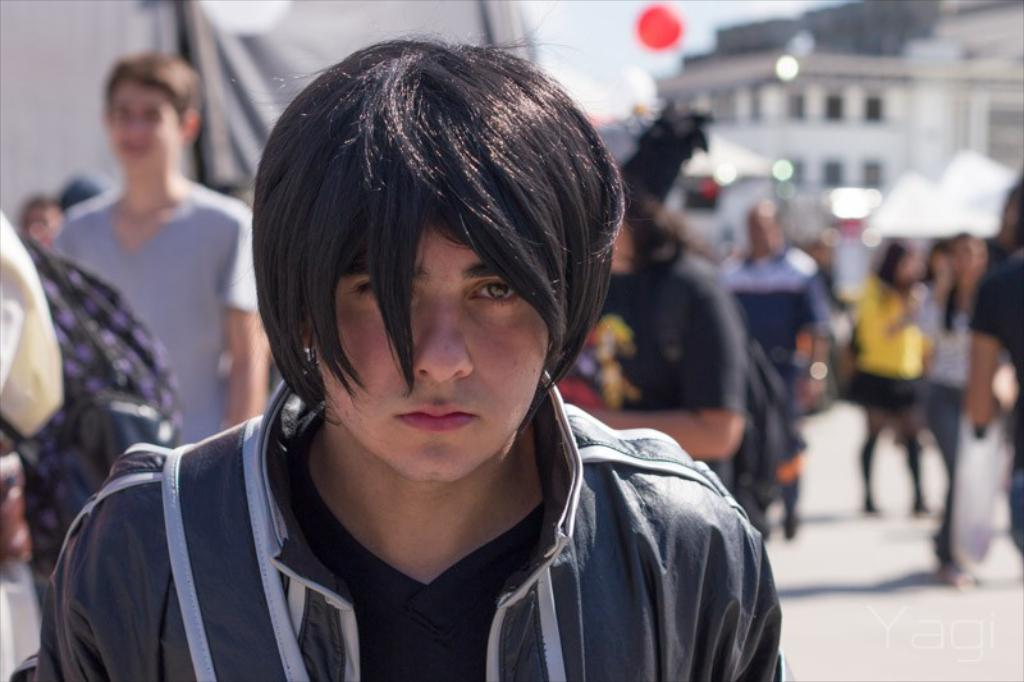What is the main subject of the image? There is a man standing in the middle of the image. What is the man doing in the image? The man is watching something. What are the people behind the man doing? The people behind the man are standing and walking. What can be seen in the background of the image? There are buildings visible at the top of the image. What additional object is present in the image? There is a balloon in the image. What type of scarf is the man wearing in the image? There is no scarf visible on the man in the image. How does the man plan to copy the earth in the image? The image does not depict the man attempting to copy the earth or any such activity. 